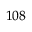<formula> <loc_0><loc_0><loc_500><loc_500>^ { 1 0 8 }</formula> 